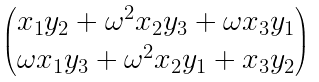<formula> <loc_0><loc_0><loc_500><loc_500>\begin{pmatrix} x _ { 1 } y _ { 2 } + \omega ^ { 2 } x _ { 2 } y _ { 3 } + \omega x _ { 3 } y _ { 1 } \\ \omega x _ { 1 } y _ { 3 } + \omega ^ { 2 } x _ { 2 } y _ { 1 } + x _ { 3 } y _ { 2 } \end{pmatrix}</formula> 